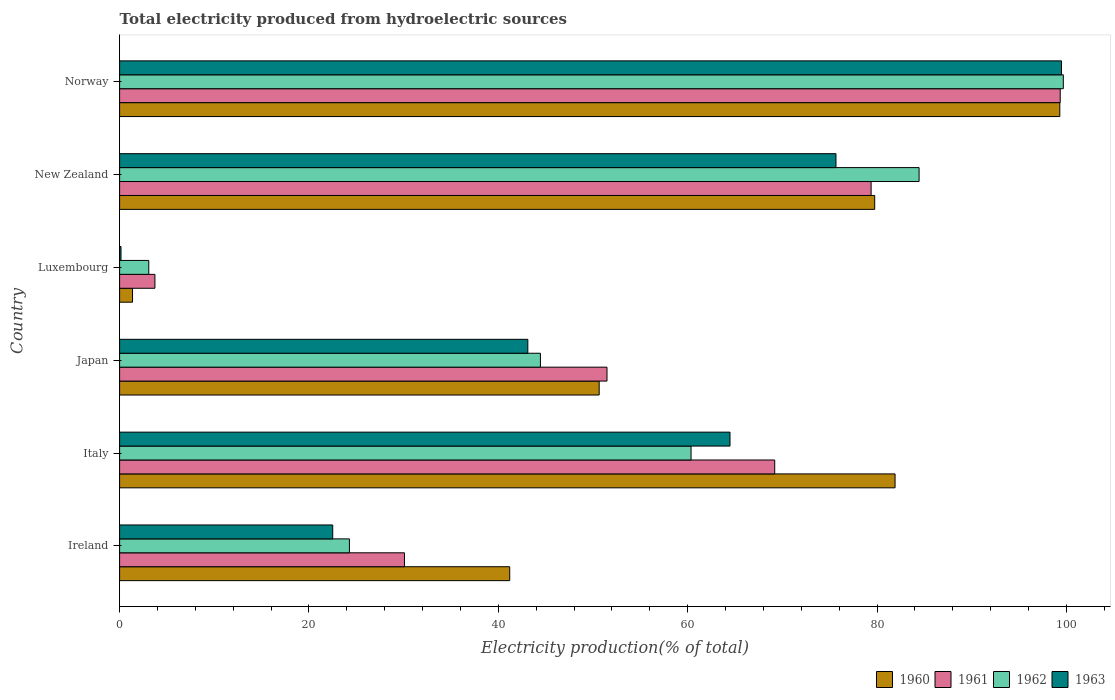Are the number of bars on each tick of the Y-axis equal?
Make the answer very short. Yes. How many bars are there on the 3rd tick from the top?
Your answer should be very brief. 4. What is the label of the 6th group of bars from the top?
Ensure brevity in your answer.  Ireland. In how many cases, is the number of bars for a given country not equal to the number of legend labels?
Your answer should be compact. 0. What is the total electricity produced in 1960 in Luxembourg?
Your answer should be compact. 1.37. Across all countries, what is the maximum total electricity produced in 1961?
Offer a terse response. 99.34. Across all countries, what is the minimum total electricity produced in 1963?
Keep it short and to the point. 0.15. In which country was the total electricity produced in 1960 maximum?
Provide a short and direct response. Norway. In which country was the total electricity produced in 1961 minimum?
Offer a very short reply. Luxembourg. What is the total total electricity produced in 1960 in the graph?
Your answer should be very brief. 354.17. What is the difference between the total electricity produced in 1961 in Luxembourg and that in New Zealand?
Your response must be concise. -75.64. What is the difference between the total electricity produced in 1962 in Japan and the total electricity produced in 1961 in Norway?
Your answer should be compact. -54.9. What is the average total electricity produced in 1961 per country?
Make the answer very short. 55.53. What is the difference between the total electricity produced in 1960 and total electricity produced in 1961 in New Zealand?
Your answer should be very brief. 0.38. What is the ratio of the total electricity produced in 1962 in New Zealand to that in Norway?
Keep it short and to the point. 0.85. Is the difference between the total electricity produced in 1960 in Italy and Luxembourg greater than the difference between the total electricity produced in 1961 in Italy and Luxembourg?
Give a very brief answer. Yes. What is the difference between the highest and the second highest total electricity produced in 1963?
Offer a terse response. 23.82. What is the difference between the highest and the lowest total electricity produced in 1962?
Offer a terse response. 96.59. Is it the case that in every country, the sum of the total electricity produced in 1962 and total electricity produced in 1960 is greater than the sum of total electricity produced in 1961 and total electricity produced in 1963?
Offer a terse response. No. What does the 3rd bar from the top in New Zealand represents?
Your answer should be very brief. 1961. Where does the legend appear in the graph?
Ensure brevity in your answer.  Bottom right. How many legend labels are there?
Your answer should be compact. 4. What is the title of the graph?
Your response must be concise. Total electricity produced from hydroelectric sources. What is the Electricity production(% of total) of 1960 in Ireland?
Give a very brief answer. 41.2. What is the Electricity production(% of total) of 1961 in Ireland?
Keep it short and to the point. 30.09. What is the Electricity production(% of total) in 1962 in Ireland?
Offer a very short reply. 24.27. What is the Electricity production(% of total) in 1963 in Ireland?
Offer a terse response. 22.51. What is the Electricity production(% of total) of 1960 in Italy?
Provide a short and direct response. 81.9. What is the Electricity production(% of total) of 1961 in Italy?
Your response must be concise. 69.19. What is the Electricity production(% of total) of 1962 in Italy?
Offer a very short reply. 60.35. What is the Electricity production(% of total) of 1963 in Italy?
Offer a terse response. 64.47. What is the Electricity production(% of total) of 1960 in Japan?
Your answer should be compact. 50.65. What is the Electricity production(% of total) in 1961 in Japan?
Your answer should be compact. 51.48. What is the Electricity production(% of total) in 1962 in Japan?
Your response must be concise. 44.44. What is the Electricity production(% of total) in 1963 in Japan?
Your answer should be very brief. 43.11. What is the Electricity production(% of total) in 1960 in Luxembourg?
Offer a very short reply. 1.37. What is the Electricity production(% of total) in 1961 in Luxembourg?
Provide a succinct answer. 3.73. What is the Electricity production(% of total) in 1962 in Luxembourg?
Provide a short and direct response. 3.08. What is the Electricity production(% of total) of 1963 in Luxembourg?
Provide a short and direct response. 0.15. What is the Electricity production(% of total) in 1960 in New Zealand?
Your answer should be compact. 79.75. What is the Electricity production(% of total) in 1961 in New Zealand?
Ensure brevity in your answer.  79.37. What is the Electricity production(% of total) of 1962 in New Zealand?
Provide a succinct answer. 84.44. What is the Electricity production(% of total) in 1963 in New Zealand?
Ensure brevity in your answer.  75.66. What is the Electricity production(% of total) in 1960 in Norway?
Provide a succinct answer. 99.3. What is the Electricity production(% of total) in 1961 in Norway?
Make the answer very short. 99.34. What is the Electricity production(% of total) in 1962 in Norway?
Provide a short and direct response. 99.67. What is the Electricity production(% of total) of 1963 in Norway?
Keep it short and to the point. 99.47. Across all countries, what is the maximum Electricity production(% of total) in 1960?
Make the answer very short. 99.3. Across all countries, what is the maximum Electricity production(% of total) of 1961?
Give a very brief answer. 99.34. Across all countries, what is the maximum Electricity production(% of total) of 1962?
Your response must be concise. 99.67. Across all countries, what is the maximum Electricity production(% of total) of 1963?
Ensure brevity in your answer.  99.47. Across all countries, what is the minimum Electricity production(% of total) in 1960?
Your answer should be very brief. 1.37. Across all countries, what is the minimum Electricity production(% of total) of 1961?
Offer a terse response. 3.73. Across all countries, what is the minimum Electricity production(% of total) in 1962?
Make the answer very short. 3.08. Across all countries, what is the minimum Electricity production(% of total) in 1963?
Provide a succinct answer. 0.15. What is the total Electricity production(% of total) in 1960 in the graph?
Your answer should be compact. 354.17. What is the total Electricity production(% of total) of 1961 in the graph?
Your answer should be very brief. 333.2. What is the total Electricity production(% of total) of 1962 in the graph?
Give a very brief answer. 316.26. What is the total Electricity production(% of total) of 1963 in the graph?
Offer a terse response. 305.37. What is the difference between the Electricity production(% of total) in 1960 in Ireland and that in Italy?
Provide a short and direct response. -40.7. What is the difference between the Electricity production(% of total) in 1961 in Ireland and that in Italy?
Your answer should be compact. -39.1. What is the difference between the Electricity production(% of total) of 1962 in Ireland and that in Italy?
Keep it short and to the point. -36.08. What is the difference between the Electricity production(% of total) in 1963 in Ireland and that in Italy?
Your answer should be very brief. -41.96. What is the difference between the Electricity production(% of total) of 1960 in Ireland and that in Japan?
Give a very brief answer. -9.45. What is the difference between the Electricity production(% of total) of 1961 in Ireland and that in Japan?
Your answer should be very brief. -21.39. What is the difference between the Electricity production(% of total) of 1962 in Ireland and that in Japan?
Your answer should be compact. -20.17. What is the difference between the Electricity production(% of total) of 1963 in Ireland and that in Japan?
Your answer should be very brief. -20.61. What is the difference between the Electricity production(% of total) of 1960 in Ireland and that in Luxembourg?
Give a very brief answer. 39.84. What is the difference between the Electricity production(% of total) of 1961 in Ireland and that in Luxembourg?
Offer a terse response. 26.36. What is the difference between the Electricity production(% of total) in 1962 in Ireland and that in Luxembourg?
Your response must be concise. 21.19. What is the difference between the Electricity production(% of total) of 1963 in Ireland and that in Luxembourg?
Offer a terse response. 22.36. What is the difference between the Electricity production(% of total) of 1960 in Ireland and that in New Zealand?
Provide a succinct answer. -38.55. What is the difference between the Electricity production(% of total) of 1961 in Ireland and that in New Zealand?
Offer a terse response. -49.29. What is the difference between the Electricity production(% of total) of 1962 in Ireland and that in New Zealand?
Offer a very short reply. -60.17. What is the difference between the Electricity production(% of total) of 1963 in Ireland and that in New Zealand?
Your answer should be compact. -53.15. What is the difference between the Electricity production(% of total) in 1960 in Ireland and that in Norway?
Keep it short and to the point. -58.1. What is the difference between the Electricity production(% of total) of 1961 in Ireland and that in Norway?
Provide a succinct answer. -69.26. What is the difference between the Electricity production(% of total) in 1962 in Ireland and that in Norway?
Give a very brief answer. -75.4. What is the difference between the Electricity production(% of total) in 1963 in Ireland and that in Norway?
Your answer should be compact. -76.97. What is the difference between the Electricity production(% of total) of 1960 in Italy and that in Japan?
Your response must be concise. 31.25. What is the difference between the Electricity production(% of total) of 1961 in Italy and that in Japan?
Offer a terse response. 17.71. What is the difference between the Electricity production(% of total) of 1962 in Italy and that in Japan?
Your response must be concise. 15.91. What is the difference between the Electricity production(% of total) in 1963 in Italy and that in Japan?
Provide a succinct answer. 21.35. What is the difference between the Electricity production(% of total) of 1960 in Italy and that in Luxembourg?
Give a very brief answer. 80.53. What is the difference between the Electricity production(% of total) of 1961 in Italy and that in Luxembourg?
Provide a short and direct response. 65.46. What is the difference between the Electricity production(% of total) of 1962 in Italy and that in Luxembourg?
Keep it short and to the point. 57.27. What is the difference between the Electricity production(% of total) in 1963 in Italy and that in Luxembourg?
Your response must be concise. 64.32. What is the difference between the Electricity production(% of total) in 1960 in Italy and that in New Zealand?
Your answer should be very brief. 2.15. What is the difference between the Electricity production(% of total) in 1961 in Italy and that in New Zealand?
Your response must be concise. -10.18. What is the difference between the Electricity production(% of total) in 1962 in Italy and that in New Zealand?
Make the answer very short. -24.08. What is the difference between the Electricity production(% of total) in 1963 in Italy and that in New Zealand?
Offer a very short reply. -11.19. What is the difference between the Electricity production(% of total) in 1960 in Italy and that in Norway?
Offer a very short reply. -17.4. What is the difference between the Electricity production(% of total) of 1961 in Italy and that in Norway?
Your answer should be very brief. -30.15. What is the difference between the Electricity production(% of total) of 1962 in Italy and that in Norway?
Keep it short and to the point. -39.32. What is the difference between the Electricity production(% of total) in 1963 in Italy and that in Norway?
Your answer should be compact. -35.01. What is the difference between the Electricity production(% of total) of 1960 in Japan and that in Luxembourg?
Provide a short and direct response. 49.28. What is the difference between the Electricity production(% of total) in 1961 in Japan and that in Luxembourg?
Provide a succinct answer. 47.75. What is the difference between the Electricity production(% of total) of 1962 in Japan and that in Luxembourg?
Provide a succinct answer. 41.36. What is the difference between the Electricity production(% of total) of 1963 in Japan and that in Luxembourg?
Your answer should be compact. 42.97. What is the difference between the Electricity production(% of total) of 1960 in Japan and that in New Zealand?
Make the answer very short. -29.1. What is the difference between the Electricity production(% of total) of 1961 in Japan and that in New Zealand?
Provide a succinct answer. -27.9. What is the difference between the Electricity production(% of total) of 1962 in Japan and that in New Zealand?
Your answer should be compact. -39.99. What is the difference between the Electricity production(% of total) in 1963 in Japan and that in New Zealand?
Provide a short and direct response. -32.54. What is the difference between the Electricity production(% of total) in 1960 in Japan and that in Norway?
Your response must be concise. -48.65. What is the difference between the Electricity production(% of total) of 1961 in Japan and that in Norway?
Give a very brief answer. -47.87. What is the difference between the Electricity production(% of total) of 1962 in Japan and that in Norway?
Ensure brevity in your answer.  -55.23. What is the difference between the Electricity production(% of total) in 1963 in Japan and that in Norway?
Your response must be concise. -56.36. What is the difference between the Electricity production(% of total) of 1960 in Luxembourg and that in New Zealand?
Give a very brief answer. -78.38. What is the difference between the Electricity production(% of total) in 1961 in Luxembourg and that in New Zealand?
Keep it short and to the point. -75.64. What is the difference between the Electricity production(% of total) in 1962 in Luxembourg and that in New Zealand?
Your response must be concise. -81.36. What is the difference between the Electricity production(% of total) in 1963 in Luxembourg and that in New Zealand?
Make the answer very short. -75.51. What is the difference between the Electricity production(% of total) in 1960 in Luxembourg and that in Norway?
Provide a succinct answer. -97.93. What is the difference between the Electricity production(% of total) of 1961 in Luxembourg and that in Norway?
Make the answer very short. -95.61. What is the difference between the Electricity production(% of total) in 1962 in Luxembourg and that in Norway?
Provide a short and direct response. -96.59. What is the difference between the Electricity production(% of total) of 1963 in Luxembourg and that in Norway?
Keep it short and to the point. -99.33. What is the difference between the Electricity production(% of total) in 1960 in New Zealand and that in Norway?
Offer a terse response. -19.55. What is the difference between the Electricity production(% of total) in 1961 in New Zealand and that in Norway?
Ensure brevity in your answer.  -19.97. What is the difference between the Electricity production(% of total) in 1962 in New Zealand and that in Norway?
Your answer should be very brief. -15.23. What is the difference between the Electricity production(% of total) in 1963 in New Zealand and that in Norway?
Your answer should be very brief. -23.82. What is the difference between the Electricity production(% of total) in 1960 in Ireland and the Electricity production(% of total) in 1961 in Italy?
Make the answer very short. -27.99. What is the difference between the Electricity production(% of total) in 1960 in Ireland and the Electricity production(% of total) in 1962 in Italy?
Give a very brief answer. -19.15. What is the difference between the Electricity production(% of total) in 1960 in Ireland and the Electricity production(% of total) in 1963 in Italy?
Provide a succinct answer. -23.27. What is the difference between the Electricity production(% of total) of 1961 in Ireland and the Electricity production(% of total) of 1962 in Italy?
Make the answer very short. -30.27. What is the difference between the Electricity production(% of total) of 1961 in Ireland and the Electricity production(% of total) of 1963 in Italy?
Provide a succinct answer. -34.38. What is the difference between the Electricity production(% of total) in 1962 in Ireland and the Electricity production(% of total) in 1963 in Italy?
Offer a very short reply. -40.2. What is the difference between the Electricity production(% of total) in 1960 in Ireland and the Electricity production(% of total) in 1961 in Japan?
Make the answer very short. -10.27. What is the difference between the Electricity production(% of total) of 1960 in Ireland and the Electricity production(% of total) of 1962 in Japan?
Your answer should be very brief. -3.24. What is the difference between the Electricity production(% of total) in 1960 in Ireland and the Electricity production(% of total) in 1963 in Japan?
Keep it short and to the point. -1.91. What is the difference between the Electricity production(% of total) in 1961 in Ireland and the Electricity production(% of total) in 1962 in Japan?
Your response must be concise. -14.36. What is the difference between the Electricity production(% of total) of 1961 in Ireland and the Electricity production(% of total) of 1963 in Japan?
Your response must be concise. -13.03. What is the difference between the Electricity production(% of total) of 1962 in Ireland and the Electricity production(% of total) of 1963 in Japan?
Keep it short and to the point. -18.84. What is the difference between the Electricity production(% of total) of 1960 in Ireland and the Electricity production(% of total) of 1961 in Luxembourg?
Keep it short and to the point. 37.47. What is the difference between the Electricity production(% of total) of 1960 in Ireland and the Electricity production(% of total) of 1962 in Luxembourg?
Your answer should be very brief. 38.12. What is the difference between the Electricity production(% of total) in 1960 in Ireland and the Electricity production(% of total) in 1963 in Luxembourg?
Provide a short and direct response. 41.05. What is the difference between the Electricity production(% of total) in 1961 in Ireland and the Electricity production(% of total) in 1962 in Luxembourg?
Keep it short and to the point. 27. What is the difference between the Electricity production(% of total) in 1961 in Ireland and the Electricity production(% of total) in 1963 in Luxembourg?
Your answer should be very brief. 29.94. What is the difference between the Electricity production(% of total) of 1962 in Ireland and the Electricity production(% of total) of 1963 in Luxembourg?
Give a very brief answer. 24.12. What is the difference between the Electricity production(% of total) of 1960 in Ireland and the Electricity production(% of total) of 1961 in New Zealand?
Your answer should be compact. -38.17. What is the difference between the Electricity production(% of total) of 1960 in Ireland and the Electricity production(% of total) of 1962 in New Zealand?
Ensure brevity in your answer.  -43.24. What is the difference between the Electricity production(% of total) of 1960 in Ireland and the Electricity production(% of total) of 1963 in New Zealand?
Provide a succinct answer. -34.46. What is the difference between the Electricity production(% of total) of 1961 in Ireland and the Electricity production(% of total) of 1962 in New Zealand?
Ensure brevity in your answer.  -54.35. What is the difference between the Electricity production(% of total) of 1961 in Ireland and the Electricity production(% of total) of 1963 in New Zealand?
Provide a succinct answer. -45.57. What is the difference between the Electricity production(% of total) of 1962 in Ireland and the Electricity production(% of total) of 1963 in New Zealand?
Make the answer very short. -51.39. What is the difference between the Electricity production(% of total) in 1960 in Ireland and the Electricity production(% of total) in 1961 in Norway?
Provide a short and direct response. -58.14. What is the difference between the Electricity production(% of total) of 1960 in Ireland and the Electricity production(% of total) of 1962 in Norway?
Your response must be concise. -58.47. What is the difference between the Electricity production(% of total) in 1960 in Ireland and the Electricity production(% of total) in 1963 in Norway?
Make the answer very short. -58.27. What is the difference between the Electricity production(% of total) in 1961 in Ireland and the Electricity production(% of total) in 1962 in Norway?
Your response must be concise. -69.58. What is the difference between the Electricity production(% of total) in 1961 in Ireland and the Electricity production(% of total) in 1963 in Norway?
Give a very brief answer. -69.39. What is the difference between the Electricity production(% of total) in 1962 in Ireland and the Electricity production(% of total) in 1963 in Norway?
Give a very brief answer. -75.2. What is the difference between the Electricity production(% of total) of 1960 in Italy and the Electricity production(% of total) of 1961 in Japan?
Your response must be concise. 30.42. What is the difference between the Electricity production(% of total) in 1960 in Italy and the Electricity production(% of total) in 1962 in Japan?
Provide a short and direct response. 37.46. What is the difference between the Electricity production(% of total) of 1960 in Italy and the Electricity production(% of total) of 1963 in Japan?
Provide a succinct answer. 38.79. What is the difference between the Electricity production(% of total) in 1961 in Italy and the Electricity production(% of total) in 1962 in Japan?
Make the answer very short. 24.75. What is the difference between the Electricity production(% of total) in 1961 in Italy and the Electricity production(% of total) in 1963 in Japan?
Your answer should be very brief. 26.08. What is the difference between the Electricity production(% of total) of 1962 in Italy and the Electricity production(% of total) of 1963 in Japan?
Make the answer very short. 17.24. What is the difference between the Electricity production(% of total) in 1960 in Italy and the Electricity production(% of total) in 1961 in Luxembourg?
Make the answer very short. 78.17. What is the difference between the Electricity production(% of total) in 1960 in Italy and the Electricity production(% of total) in 1962 in Luxembourg?
Make the answer very short. 78.82. What is the difference between the Electricity production(% of total) in 1960 in Italy and the Electricity production(% of total) in 1963 in Luxembourg?
Your answer should be very brief. 81.75. What is the difference between the Electricity production(% of total) of 1961 in Italy and the Electricity production(% of total) of 1962 in Luxembourg?
Your answer should be very brief. 66.11. What is the difference between the Electricity production(% of total) in 1961 in Italy and the Electricity production(% of total) in 1963 in Luxembourg?
Ensure brevity in your answer.  69.04. What is the difference between the Electricity production(% of total) in 1962 in Italy and the Electricity production(% of total) in 1963 in Luxembourg?
Provide a succinct answer. 60.21. What is the difference between the Electricity production(% of total) in 1960 in Italy and the Electricity production(% of total) in 1961 in New Zealand?
Your response must be concise. 2.53. What is the difference between the Electricity production(% of total) in 1960 in Italy and the Electricity production(% of total) in 1962 in New Zealand?
Provide a short and direct response. -2.54. What is the difference between the Electricity production(% of total) in 1960 in Italy and the Electricity production(% of total) in 1963 in New Zealand?
Your response must be concise. 6.24. What is the difference between the Electricity production(% of total) in 1961 in Italy and the Electricity production(% of total) in 1962 in New Zealand?
Your answer should be compact. -15.25. What is the difference between the Electricity production(% of total) of 1961 in Italy and the Electricity production(% of total) of 1963 in New Zealand?
Your response must be concise. -6.47. What is the difference between the Electricity production(% of total) of 1962 in Italy and the Electricity production(% of total) of 1963 in New Zealand?
Keep it short and to the point. -15.3. What is the difference between the Electricity production(% of total) in 1960 in Italy and the Electricity production(% of total) in 1961 in Norway?
Your answer should be compact. -17.44. What is the difference between the Electricity production(% of total) in 1960 in Italy and the Electricity production(% of total) in 1962 in Norway?
Provide a short and direct response. -17.77. What is the difference between the Electricity production(% of total) in 1960 in Italy and the Electricity production(% of total) in 1963 in Norway?
Your answer should be compact. -17.57. What is the difference between the Electricity production(% of total) of 1961 in Italy and the Electricity production(% of total) of 1962 in Norway?
Offer a terse response. -30.48. What is the difference between the Electricity production(% of total) of 1961 in Italy and the Electricity production(% of total) of 1963 in Norway?
Provide a succinct answer. -30.28. What is the difference between the Electricity production(% of total) in 1962 in Italy and the Electricity production(% of total) in 1963 in Norway?
Keep it short and to the point. -39.12. What is the difference between the Electricity production(% of total) in 1960 in Japan and the Electricity production(% of total) in 1961 in Luxembourg?
Your answer should be compact. 46.92. What is the difference between the Electricity production(% of total) of 1960 in Japan and the Electricity production(% of total) of 1962 in Luxembourg?
Offer a terse response. 47.57. What is the difference between the Electricity production(% of total) in 1960 in Japan and the Electricity production(% of total) in 1963 in Luxembourg?
Keep it short and to the point. 50.5. What is the difference between the Electricity production(% of total) of 1961 in Japan and the Electricity production(% of total) of 1962 in Luxembourg?
Offer a very short reply. 48.39. What is the difference between the Electricity production(% of total) of 1961 in Japan and the Electricity production(% of total) of 1963 in Luxembourg?
Keep it short and to the point. 51.33. What is the difference between the Electricity production(% of total) in 1962 in Japan and the Electricity production(% of total) in 1963 in Luxembourg?
Give a very brief answer. 44.3. What is the difference between the Electricity production(% of total) in 1960 in Japan and the Electricity production(% of total) in 1961 in New Zealand?
Make the answer very short. -28.72. What is the difference between the Electricity production(% of total) in 1960 in Japan and the Electricity production(% of total) in 1962 in New Zealand?
Ensure brevity in your answer.  -33.79. What is the difference between the Electricity production(% of total) of 1960 in Japan and the Electricity production(% of total) of 1963 in New Zealand?
Give a very brief answer. -25.01. What is the difference between the Electricity production(% of total) in 1961 in Japan and the Electricity production(% of total) in 1962 in New Zealand?
Your answer should be very brief. -32.96. What is the difference between the Electricity production(% of total) of 1961 in Japan and the Electricity production(% of total) of 1963 in New Zealand?
Your answer should be very brief. -24.18. What is the difference between the Electricity production(% of total) in 1962 in Japan and the Electricity production(% of total) in 1963 in New Zealand?
Keep it short and to the point. -31.21. What is the difference between the Electricity production(% of total) of 1960 in Japan and the Electricity production(% of total) of 1961 in Norway?
Give a very brief answer. -48.69. What is the difference between the Electricity production(% of total) of 1960 in Japan and the Electricity production(% of total) of 1962 in Norway?
Make the answer very short. -49.02. What is the difference between the Electricity production(% of total) of 1960 in Japan and the Electricity production(% of total) of 1963 in Norway?
Your response must be concise. -48.83. What is the difference between the Electricity production(% of total) in 1961 in Japan and the Electricity production(% of total) in 1962 in Norway?
Keep it short and to the point. -48.19. What is the difference between the Electricity production(% of total) of 1961 in Japan and the Electricity production(% of total) of 1963 in Norway?
Ensure brevity in your answer.  -48. What is the difference between the Electricity production(% of total) of 1962 in Japan and the Electricity production(% of total) of 1963 in Norway?
Ensure brevity in your answer.  -55.03. What is the difference between the Electricity production(% of total) of 1960 in Luxembourg and the Electricity production(% of total) of 1961 in New Zealand?
Give a very brief answer. -78.01. What is the difference between the Electricity production(% of total) in 1960 in Luxembourg and the Electricity production(% of total) in 1962 in New Zealand?
Offer a very short reply. -83.07. What is the difference between the Electricity production(% of total) in 1960 in Luxembourg and the Electricity production(% of total) in 1963 in New Zealand?
Provide a short and direct response. -74.29. What is the difference between the Electricity production(% of total) in 1961 in Luxembourg and the Electricity production(% of total) in 1962 in New Zealand?
Provide a succinct answer. -80.71. What is the difference between the Electricity production(% of total) of 1961 in Luxembourg and the Electricity production(% of total) of 1963 in New Zealand?
Offer a very short reply. -71.93. What is the difference between the Electricity production(% of total) in 1962 in Luxembourg and the Electricity production(% of total) in 1963 in New Zealand?
Your response must be concise. -72.58. What is the difference between the Electricity production(% of total) of 1960 in Luxembourg and the Electricity production(% of total) of 1961 in Norway?
Make the answer very short. -97.98. What is the difference between the Electricity production(% of total) of 1960 in Luxembourg and the Electricity production(% of total) of 1962 in Norway?
Offer a terse response. -98.3. What is the difference between the Electricity production(% of total) of 1960 in Luxembourg and the Electricity production(% of total) of 1963 in Norway?
Your response must be concise. -98.11. What is the difference between the Electricity production(% of total) of 1961 in Luxembourg and the Electricity production(% of total) of 1962 in Norway?
Keep it short and to the point. -95.94. What is the difference between the Electricity production(% of total) in 1961 in Luxembourg and the Electricity production(% of total) in 1963 in Norway?
Provide a succinct answer. -95.74. What is the difference between the Electricity production(% of total) of 1962 in Luxembourg and the Electricity production(% of total) of 1963 in Norway?
Your response must be concise. -96.39. What is the difference between the Electricity production(% of total) of 1960 in New Zealand and the Electricity production(% of total) of 1961 in Norway?
Your answer should be very brief. -19.59. What is the difference between the Electricity production(% of total) in 1960 in New Zealand and the Electricity production(% of total) in 1962 in Norway?
Provide a short and direct response. -19.92. What is the difference between the Electricity production(% of total) in 1960 in New Zealand and the Electricity production(% of total) in 1963 in Norway?
Provide a succinct answer. -19.72. What is the difference between the Electricity production(% of total) in 1961 in New Zealand and the Electricity production(% of total) in 1962 in Norway?
Your answer should be compact. -20.3. What is the difference between the Electricity production(% of total) of 1961 in New Zealand and the Electricity production(% of total) of 1963 in Norway?
Your response must be concise. -20.1. What is the difference between the Electricity production(% of total) of 1962 in New Zealand and the Electricity production(% of total) of 1963 in Norway?
Provide a short and direct response. -15.04. What is the average Electricity production(% of total) in 1960 per country?
Make the answer very short. 59.03. What is the average Electricity production(% of total) of 1961 per country?
Your response must be concise. 55.53. What is the average Electricity production(% of total) in 1962 per country?
Your answer should be compact. 52.71. What is the average Electricity production(% of total) of 1963 per country?
Your answer should be compact. 50.9. What is the difference between the Electricity production(% of total) in 1960 and Electricity production(% of total) in 1961 in Ireland?
Your answer should be compact. 11.12. What is the difference between the Electricity production(% of total) of 1960 and Electricity production(% of total) of 1962 in Ireland?
Your response must be concise. 16.93. What is the difference between the Electricity production(% of total) of 1960 and Electricity production(% of total) of 1963 in Ireland?
Make the answer very short. 18.69. What is the difference between the Electricity production(% of total) in 1961 and Electricity production(% of total) in 1962 in Ireland?
Give a very brief answer. 5.81. What is the difference between the Electricity production(% of total) in 1961 and Electricity production(% of total) in 1963 in Ireland?
Provide a short and direct response. 7.58. What is the difference between the Electricity production(% of total) in 1962 and Electricity production(% of total) in 1963 in Ireland?
Provide a succinct answer. 1.76. What is the difference between the Electricity production(% of total) of 1960 and Electricity production(% of total) of 1961 in Italy?
Your response must be concise. 12.71. What is the difference between the Electricity production(% of total) in 1960 and Electricity production(% of total) in 1962 in Italy?
Provide a short and direct response. 21.55. What is the difference between the Electricity production(% of total) in 1960 and Electricity production(% of total) in 1963 in Italy?
Offer a very short reply. 17.43. What is the difference between the Electricity production(% of total) in 1961 and Electricity production(% of total) in 1962 in Italy?
Your answer should be very brief. 8.84. What is the difference between the Electricity production(% of total) of 1961 and Electricity production(% of total) of 1963 in Italy?
Ensure brevity in your answer.  4.72. What is the difference between the Electricity production(% of total) in 1962 and Electricity production(% of total) in 1963 in Italy?
Offer a terse response. -4.11. What is the difference between the Electricity production(% of total) of 1960 and Electricity production(% of total) of 1961 in Japan?
Your answer should be very brief. -0.83. What is the difference between the Electricity production(% of total) of 1960 and Electricity production(% of total) of 1962 in Japan?
Give a very brief answer. 6.2. What is the difference between the Electricity production(% of total) of 1960 and Electricity production(% of total) of 1963 in Japan?
Your answer should be compact. 7.54. What is the difference between the Electricity production(% of total) of 1961 and Electricity production(% of total) of 1962 in Japan?
Give a very brief answer. 7.03. What is the difference between the Electricity production(% of total) in 1961 and Electricity production(% of total) in 1963 in Japan?
Your answer should be compact. 8.36. What is the difference between the Electricity production(% of total) in 1962 and Electricity production(% of total) in 1963 in Japan?
Provide a succinct answer. 1.33. What is the difference between the Electricity production(% of total) in 1960 and Electricity production(% of total) in 1961 in Luxembourg?
Provide a succinct answer. -2.36. What is the difference between the Electricity production(% of total) in 1960 and Electricity production(% of total) in 1962 in Luxembourg?
Your response must be concise. -1.72. What is the difference between the Electricity production(% of total) of 1960 and Electricity production(% of total) of 1963 in Luxembourg?
Your answer should be very brief. 1.22. What is the difference between the Electricity production(% of total) of 1961 and Electricity production(% of total) of 1962 in Luxembourg?
Your answer should be compact. 0.65. What is the difference between the Electricity production(% of total) in 1961 and Electricity production(% of total) in 1963 in Luxembourg?
Keep it short and to the point. 3.58. What is the difference between the Electricity production(% of total) of 1962 and Electricity production(% of total) of 1963 in Luxembourg?
Give a very brief answer. 2.93. What is the difference between the Electricity production(% of total) in 1960 and Electricity production(% of total) in 1961 in New Zealand?
Give a very brief answer. 0.38. What is the difference between the Electricity production(% of total) of 1960 and Electricity production(% of total) of 1962 in New Zealand?
Your response must be concise. -4.69. What is the difference between the Electricity production(% of total) of 1960 and Electricity production(% of total) of 1963 in New Zealand?
Your response must be concise. 4.09. What is the difference between the Electricity production(% of total) in 1961 and Electricity production(% of total) in 1962 in New Zealand?
Offer a very short reply. -5.07. What is the difference between the Electricity production(% of total) of 1961 and Electricity production(% of total) of 1963 in New Zealand?
Give a very brief answer. 3.71. What is the difference between the Electricity production(% of total) of 1962 and Electricity production(% of total) of 1963 in New Zealand?
Offer a terse response. 8.78. What is the difference between the Electricity production(% of total) in 1960 and Electricity production(% of total) in 1961 in Norway?
Provide a succinct answer. -0.04. What is the difference between the Electricity production(% of total) of 1960 and Electricity production(% of total) of 1962 in Norway?
Your answer should be compact. -0.37. What is the difference between the Electricity production(% of total) of 1960 and Electricity production(% of total) of 1963 in Norway?
Your response must be concise. -0.17. What is the difference between the Electricity production(% of total) of 1961 and Electricity production(% of total) of 1962 in Norway?
Offer a very short reply. -0.33. What is the difference between the Electricity production(% of total) in 1961 and Electricity production(% of total) in 1963 in Norway?
Give a very brief answer. -0.13. What is the difference between the Electricity production(% of total) of 1962 and Electricity production(% of total) of 1963 in Norway?
Your answer should be very brief. 0.19. What is the ratio of the Electricity production(% of total) of 1960 in Ireland to that in Italy?
Ensure brevity in your answer.  0.5. What is the ratio of the Electricity production(% of total) of 1961 in Ireland to that in Italy?
Give a very brief answer. 0.43. What is the ratio of the Electricity production(% of total) in 1962 in Ireland to that in Italy?
Make the answer very short. 0.4. What is the ratio of the Electricity production(% of total) in 1963 in Ireland to that in Italy?
Offer a very short reply. 0.35. What is the ratio of the Electricity production(% of total) of 1960 in Ireland to that in Japan?
Your answer should be compact. 0.81. What is the ratio of the Electricity production(% of total) of 1961 in Ireland to that in Japan?
Keep it short and to the point. 0.58. What is the ratio of the Electricity production(% of total) in 1962 in Ireland to that in Japan?
Make the answer very short. 0.55. What is the ratio of the Electricity production(% of total) in 1963 in Ireland to that in Japan?
Give a very brief answer. 0.52. What is the ratio of the Electricity production(% of total) of 1960 in Ireland to that in Luxembourg?
Keep it short and to the point. 30.16. What is the ratio of the Electricity production(% of total) in 1961 in Ireland to that in Luxembourg?
Make the answer very short. 8.07. What is the ratio of the Electricity production(% of total) of 1962 in Ireland to that in Luxembourg?
Keep it short and to the point. 7.88. What is the ratio of the Electricity production(% of total) in 1963 in Ireland to that in Luxembourg?
Give a very brief answer. 152.5. What is the ratio of the Electricity production(% of total) of 1960 in Ireland to that in New Zealand?
Your answer should be compact. 0.52. What is the ratio of the Electricity production(% of total) of 1961 in Ireland to that in New Zealand?
Your response must be concise. 0.38. What is the ratio of the Electricity production(% of total) in 1962 in Ireland to that in New Zealand?
Keep it short and to the point. 0.29. What is the ratio of the Electricity production(% of total) of 1963 in Ireland to that in New Zealand?
Ensure brevity in your answer.  0.3. What is the ratio of the Electricity production(% of total) in 1960 in Ireland to that in Norway?
Ensure brevity in your answer.  0.41. What is the ratio of the Electricity production(% of total) in 1961 in Ireland to that in Norway?
Offer a terse response. 0.3. What is the ratio of the Electricity production(% of total) of 1962 in Ireland to that in Norway?
Your response must be concise. 0.24. What is the ratio of the Electricity production(% of total) in 1963 in Ireland to that in Norway?
Offer a very short reply. 0.23. What is the ratio of the Electricity production(% of total) in 1960 in Italy to that in Japan?
Provide a succinct answer. 1.62. What is the ratio of the Electricity production(% of total) in 1961 in Italy to that in Japan?
Provide a succinct answer. 1.34. What is the ratio of the Electricity production(% of total) in 1962 in Italy to that in Japan?
Provide a succinct answer. 1.36. What is the ratio of the Electricity production(% of total) of 1963 in Italy to that in Japan?
Give a very brief answer. 1.5. What is the ratio of the Electricity production(% of total) in 1960 in Italy to that in Luxembourg?
Your answer should be very brief. 59.95. What is the ratio of the Electricity production(% of total) in 1961 in Italy to that in Luxembourg?
Give a very brief answer. 18.55. What is the ratio of the Electricity production(% of total) in 1962 in Italy to that in Luxembourg?
Offer a terse response. 19.58. What is the ratio of the Electricity production(% of total) of 1963 in Italy to that in Luxembourg?
Make the answer very short. 436.77. What is the ratio of the Electricity production(% of total) in 1960 in Italy to that in New Zealand?
Your response must be concise. 1.03. What is the ratio of the Electricity production(% of total) of 1961 in Italy to that in New Zealand?
Give a very brief answer. 0.87. What is the ratio of the Electricity production(% of total) in 1962 in Italy to that in New Zealand?
Provide a succinct answer. 0.71. What is the ratio of the Electricity production(% of total) in 1963 in Italy to that in New Zealand?
Make the answer very short. 0.85. What is the ratio of the Electricity production(% of total) of 1960 in Italy to that in Norway?
Provide a short and direct response. 0.82. What is the ratio of the Electricity production(% of total) in 1961 in Italy to that in Norway?
Offer a terse response. 0.7. What is the ratio of the Electricity production(% of total) in 1962 in Italy to that in Norway?
Make the answer very short. 0.61. What is the ratio of the Electricity production(% of total) in 1963 in Italy to that in Norway?
Ensure brevity in your answer.  0.65. What is the ratio of the Electricity production(% of total) in 1960 in Japan to that in Luxembourg?
Make the answer very short. 37.08. What is the ratio of the Electricity production(% of total) of 1961 in Japan to that in Luxembourg?
Make the answer very short. 13.8. What is the ratio of the Electricity production(% of total) of 1962 in Japan to that in Luxembourg?
Provide a succinct answer. 14.42. What is the ratio of the Electricity production(% of total) in 1963 in Japan to that in Luxembourg?
Your answer should be compact. 292.1. What is the ratio of the Electricity production(% of total) of 1960 in Japan to that in New Zealand?
Make the answer very short. 0.64. What is the ratio of the Electricity production(% of total) of 1961 in Japan to that in New Zealand?
Your answer should be very brief. 0.65. What is the ratio of the Electricity production(% of total) in 1962 in Japan to that in New Zealand?
Keep it short and to the point. 0.53. What is the ratio of the Electricity production(% of total) of 1963 in Japan to that in New Zealand?
Your answer should be compact. 0.57. What is the ratio of the Electricity production(% of total) in 1960 in Japan to that in Norway?
Provide a succinct answer. 0.51. What is the ratio of the Electricity production(% of total) in 1961 in Japan to that in Norway?
Offer a very short reply. 0.52. What is the ratio of the Electricity production(% of total) in 1962 in Japan to that in Norway?
Provide a succinct answer. 0.45. What is the ratio of the Electricity production(% of total) of 1963 in Japan to that in Norway?
Ensure brevity in your answer.  0.43. What is the ratio of the Electricity production(% of total) of 1960 in Luxembourg to that in New Zealand?
Offer a terse response. 0.02. What is the ratio of the Electricity production(% of total) in 1961 in Luxembourg to that in New Zealand?
Offer a terse response. 0.05. What is the ratio of the Electricity production(% of total) in 1962 in Luxembourg to that in New Zealand?
Ensure brevity in your answer.  0.04. What is the ratio of the Electricity production(% of total) of 1963 in Luxembourg to that in New Zealand?
Ensure brevity in your answer.  0. What is the ratio of the Electricity production(% of total) of 1960 in Luxembourg to that in Norway?
Ensure brevity in your answer.  0.01. What is the ratio of the Electricity production(% of total) in 1961 in Luxembourg to that in Norway?
Offer a terse response. 0.04. What is the ratio of the Electricity production(% of total) in 1962 in Luxembourg to that in Norway?
Your answer should be compact. 0.03. What is the ratio of the Electricity production(% of total) in 1963 in Luxembourg to that in Norway?
Keep it short and to the point. 0. What is the ratio of the Electricity production(% of total) in 1960 in New Zealand to that in Norway?
Give a very brief answer. 0.8. What is the ratio of the Electricity production(% of total) of 1961 in New Zealand to that in Norway?
Provide a succinct answer. 0.8. What is the ratio of the Electricity production(% of total) of 1962 in New Zealand to that in Norway?
Give a very brief answer. 0.85. What is the ratio of the Electricity production(% of total) in 1963 in New Zealand to that in Norway?
Keep it short and to the point. 0.76. What is the difference between the highest and the second highest Electricity production(% of total) in 1961?
Make the answer very short. 19.97. What is the difference between the highest and the second highest Electricity production(% of total) in 1962?
Provide a short and direct response. 15.23. What is the difference between the highest and the second highest Electricity production(% of total) of 1963?
Offer a terse response. 23.82. What is the difference between the highest and the lowest Electricity production(% of total) in 1960?
Your answer should be compact. 97.93. What is the difference between the highest and the lowest Electricity production(% of total) of 1961?
Your response must be concise. 95.61. What is the difference between the highest and the lowest Electricity production(% of total) of 1962?
Offer a very short reply. 96.59. What is the difference between the highest and the lowest Electricity production(% of total) of 1963?
Provide a short and direct response. 99.33. 